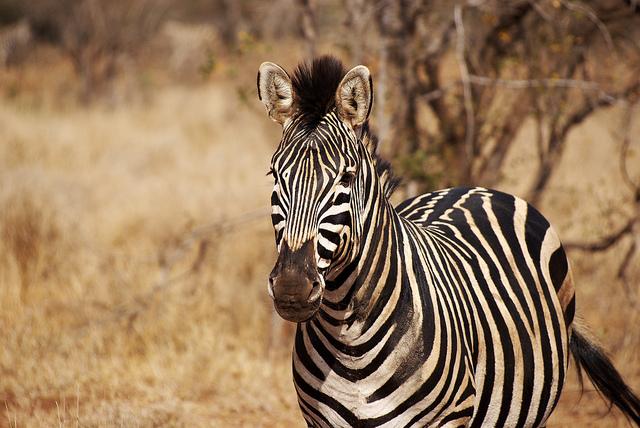What direction is the zebra facing?
Be succinct. Forward. Is this a baby animal or an adult animal?
Concise answer only. Adult. Is the zebra in a dry landscape?
Write a very short answer. Yes. Can you see the Zebra's tail?
Write a very short answer. Yes. How many zebras are there?
Quick response, please. 1. 